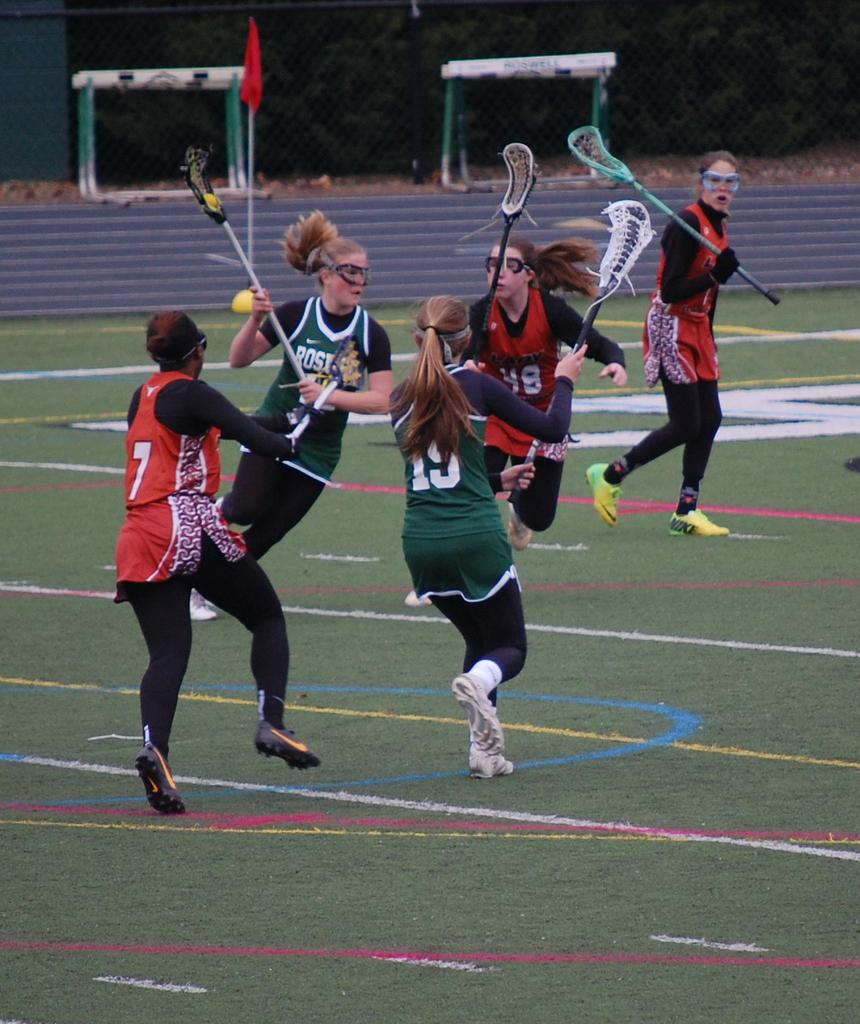How many people are in the image? There is a group of people in the image. What are the people wearing? The people are wearing clothes. What are the people holding in their hands? The people are holding sticks in their hands. What can be seen in the top left and top right of the image? There are goals in the top left and top right of the image. Can you see a baby playing with a beetle in the image? No, there is no baby or beetle present in the image. 